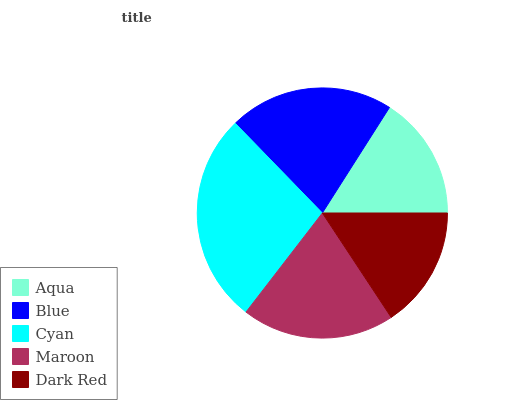Is Dark Red the minimum?
Answer yes or no. Yes. Is Cyan the maximum?
Answer yes or no. Yes. Is Blue the minimum?
Answer yes or no. No. Is Blue the maximum?
Answer yes or no. No. Is Blue greater than Aqua?
Answer yes or no. Yes. Is Aqua less than Blue?
Answer yes or no. Yes. Is Aqua greater than Blue?
Answer yes or no. No. Is Blue less than Aqua?
Answer yes or no. No. Is Maroon the high median?
Answer yes or no. Yes. Is Maroon the low median?
Answer yes or no. Yes. Is Dark Red the high median?
Answer yes or no. No. Is Dark Red the low median?
Answer yes or no. No. 